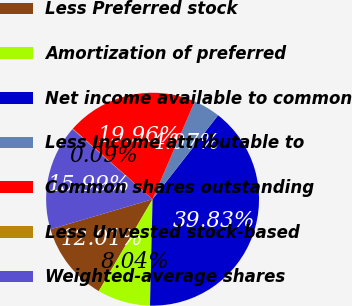Convert chart. <chart><loc_0><loc_0><loc_500><loc_500><pie_chart><fcel>Less Preferred stock<fcel>Amortization of preferred<fcel>Net income available to common<fcel>Less Income attributable to<fcel>Common shares outstanding<fcel>Less Unvested stock-based<fcel>Weighted-average shares<nl><fcel>12.01%<fcel>8.04%<fcel>39.83%<fcel>4.07%<fcel>19.96%<fcel>0.09%<fcel>15.99%<nl></chart> 